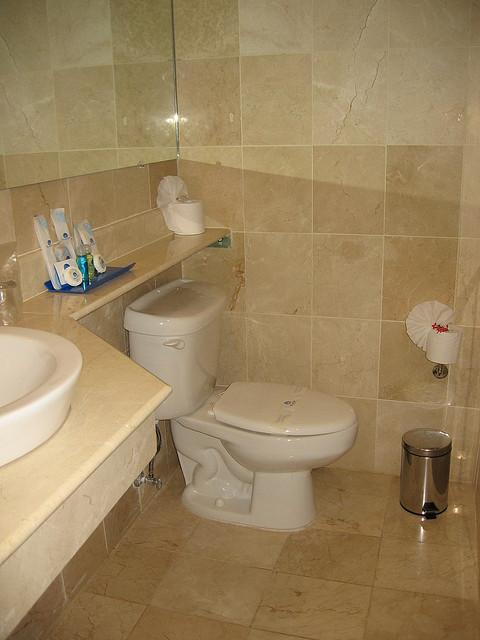Where is this bathroom located? hotel 